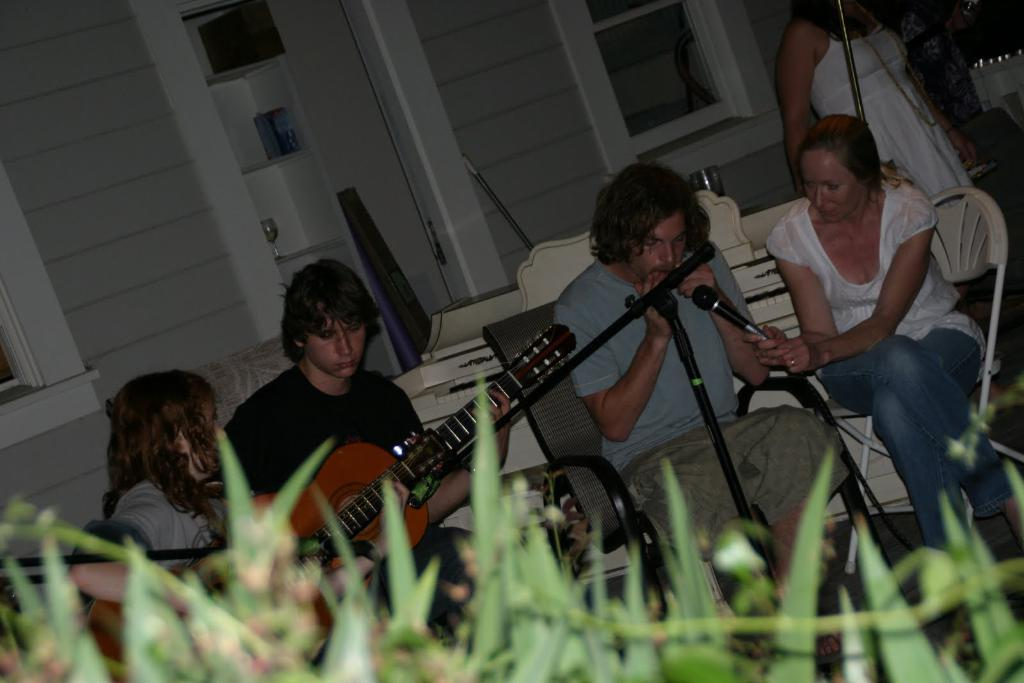What are the people in the image doing? The people in the image are sitting on chairs and holding guitars in their hands. Can you describe the woman in the image? The woman in the image is holding a microphone in her hand. What objects are being used by the people in the image? The people are using guitars and a microphone in the image. What type of test is being conducted in the image? There is no test being conducted in the image; it features people sitting on chairs and holding guitars, with a woman holding a microphone. Can you see any shops in the image? There are no shops present in the image. 